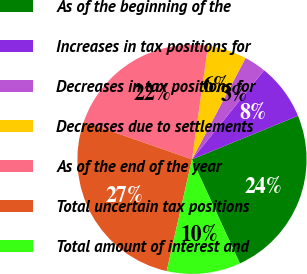Convert chart. <chart><loc_0><loc_0><loc_500><loc_500><pie_chart><fcel>As of the beginning of the<fcel>Increases in tax positions for<fcel>Decreases in tax positions for<fcel>Decreases due to settlements<fcel>As of the end of the year<fcel>Total uncertain tax positions<fcel>Total amount of interest and<nl><fcel>24.34%<fcel>7.97%<fcel>3.08%<fcel>5.52%<fcel>21.9%<fcel>26.79%<fcel>10.41%<nl></chart> 